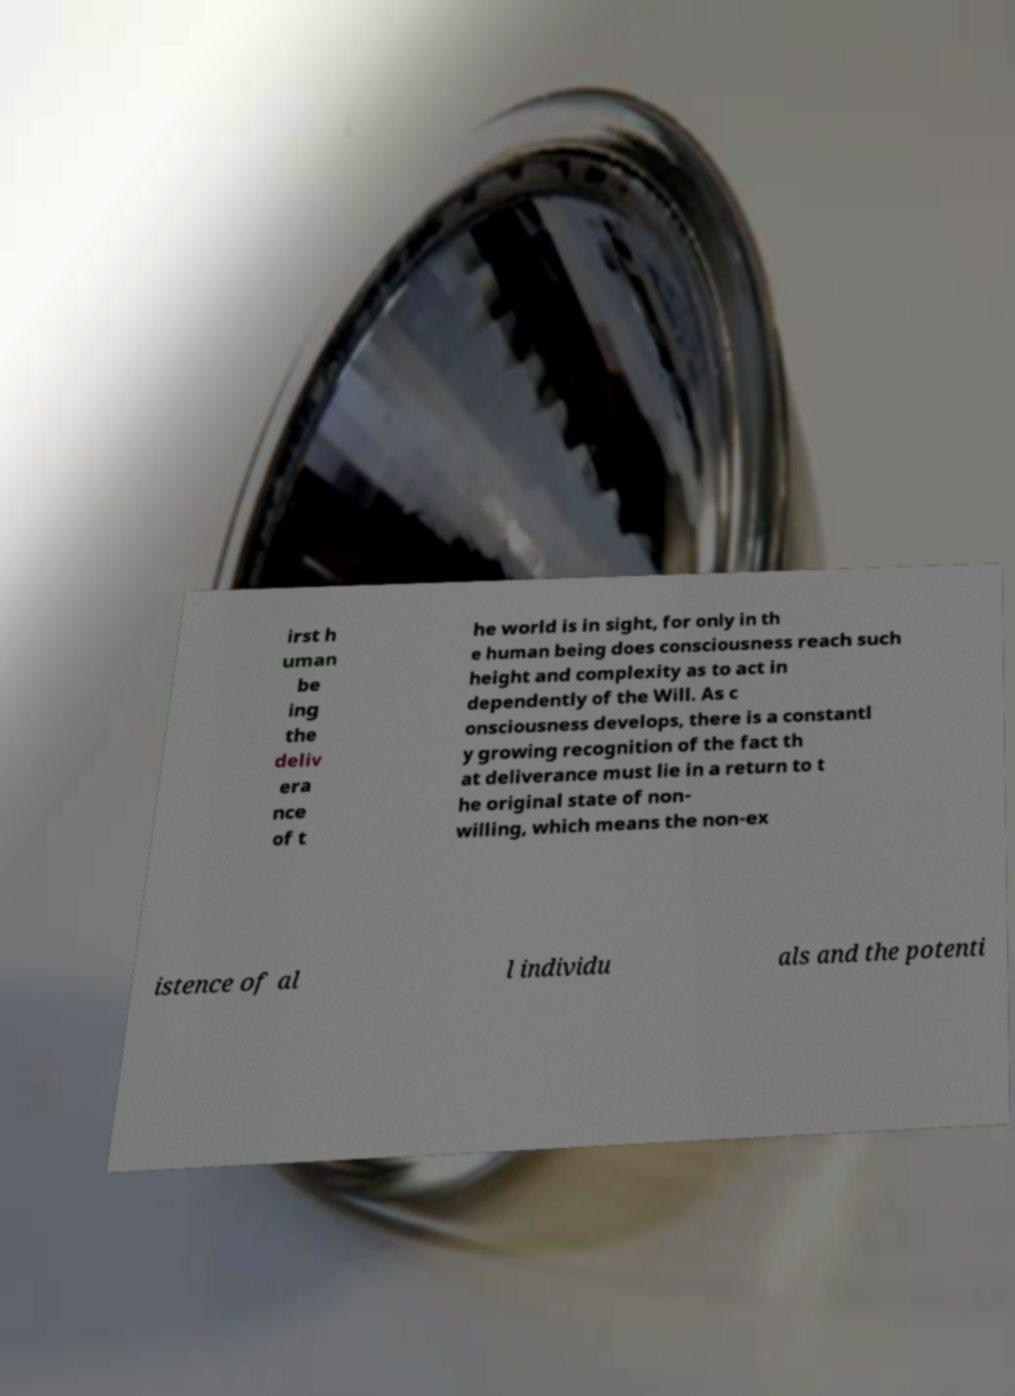Please read and relay the text visible in this image. What does it say? irst h uman be ing the deliv era nce of t he world is in sight, for only in th e human being does consciousness reach such height and complexity as to act in dependently of the Will. As c onsciousness develops, there is a constantl y growing recognition of the fact th at deliverance must lie in a return to t he original state of non- willing, which means the non-ex istence of al l individu als and the potenti 